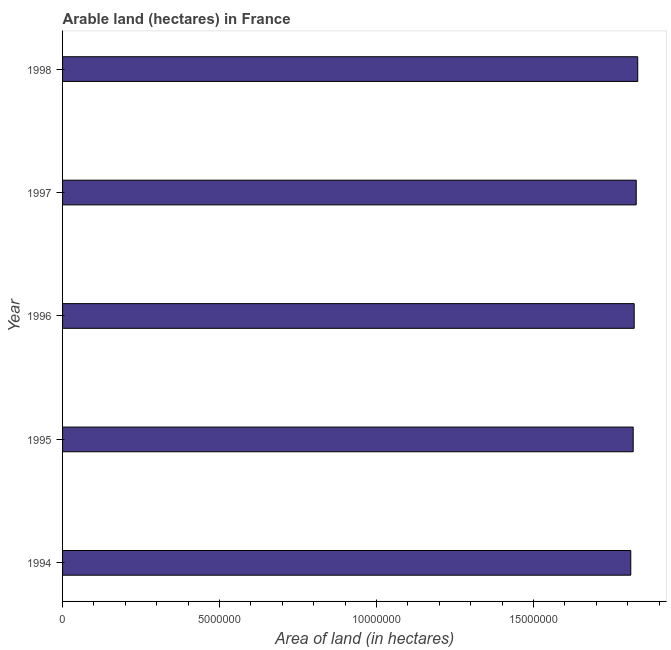Does the graph contain any zero values?
Give a very brief answer. No. What is the title of the graph?
Your answer should be very brief. Arable land (hectares) in France. What is the label or title of the X-axis?
Offer a very short reply. Area of land (in hectares). What is the label or title of the Y-axis?
Ensure brevity in your answer.  Year. What is the area of land in 1996?
Your answer should be very brief. 1.82e+07. Across all years, what is the maximum area of land?
Your answer should be very brief. 1.83e+07. Across all years, what is the minimum area of land?
Keep it short and to the point. 1.81e+07. In which year was the area of land maximum?
Your answer should be compact. 1998. What is the sum of the area of land?
Keep it short and to the point. 9.11e+07. What is the difference between the area of land in 1997 and 1998?
Provide a succinct answer. -4.79e+04. What is the average area of land per year?
Give a very brief answer. 1.82e+07. What is the median area of land?
Ensure brevity in your answer.  1.82e+07. Do a majority of the years between 1995 and 1994 (inclusive) have area of land greater than 15000000 hectares?
Ensure brevity in your answer.  No. Is the area of land in 1994 less than that in 1997?
Make the answer very short. Yes. Is the difference between the area of land in 1994 and 1997 greater than the difference between any two years?
Your answer should be compact. No. What is the difference between the highest and the second highest area of land?
Offer a terse response. 4.79e+04. What is the difference between the highest and the lowest area of land?
Offer a terse response. 2.22e+05. In how many years, is the area of land greater than the average area of land taken over all years?
Make the answer very short. 2. How many bars are there?
Your answer should be compact. 5. What is the Area of land (in hectares) of 1994?
Provide a succinct answer. 1.81e+07. What is the Area of land (in hectares) of 1995?
Your answer should be very brief. 1.82e+07. What is the Area of land (in hectares) of 1996?
Keep it short and to the point. 1.82e+07. What is the Area of land (in hectares) in 1997?
Ensure brevity in your answer.  1.83e+07. What is the Area of land (in hectares) of 1998?
Offer a very short reply. 1.83e+07. What is the difference between the Area of land (in hectares) in 1994 and 1995?
Ensure brevity in your answer.  -7.69e+04. What is the difference between the Area of land (in hectares) in 1994 and 1996?
Your answer should be compact. -1.09e+05. What is the difference between the Area of land (in hectares) in 1994 and 1997?
Offer a terse response. -1.74e+05. What is the difference between the Area of land (in hectares) in 1994 and 1998?
Your answer should be very brief. -2.22e+05. What is the difference between the Area of land (in hectares) in 1995 and 1996?
Your answer should be compact. -3.19e+04. What is the difference between the Area of land (in hectares) in 1995 and 1997?
Keep it short and to the point. -9.70e+04. What is the difference between the Area of land (in hectares) in 1995 and 1998?
Ensure brevity in your answer.  -1.45e+05. What is the difference between the Area of land (in hectares) in 1996 and 1997?
Offer a terse response. -6.51e+04. What is the difference between the Area of land (in hectares) in 1996 and 1998?
Offer a terse response. -1.13e+05. What is the difference between the Area of land (in hectares) in 1997 and 1998?
Offer a very short reply. -4.79e+04. What is the ratio of the Area of land (in hectares) in 1994 to that in 1996?
Offer a terse response. 0.99. What is the ratio of the Area of land (in hectares) in 1994 to that in 1998?
Provide a short and direct response. 0.99. What is the ratio of the Area of land (in hectares) in 1995 to that in 1996?
Offer a very short reply. 1. What is the ratio of the Area of land (in hectares) in 1995 to that in 1997?
Your answer should be compact. 0.99. What is the ratio of the Area of land (in hectares) in 1995 to that in 1998?
Keep it short and to the point. 0.99. What is the ratio of the Area of land (in hectares) in 1996 to that in 1998?
Offer a very short reply. 0.99. 